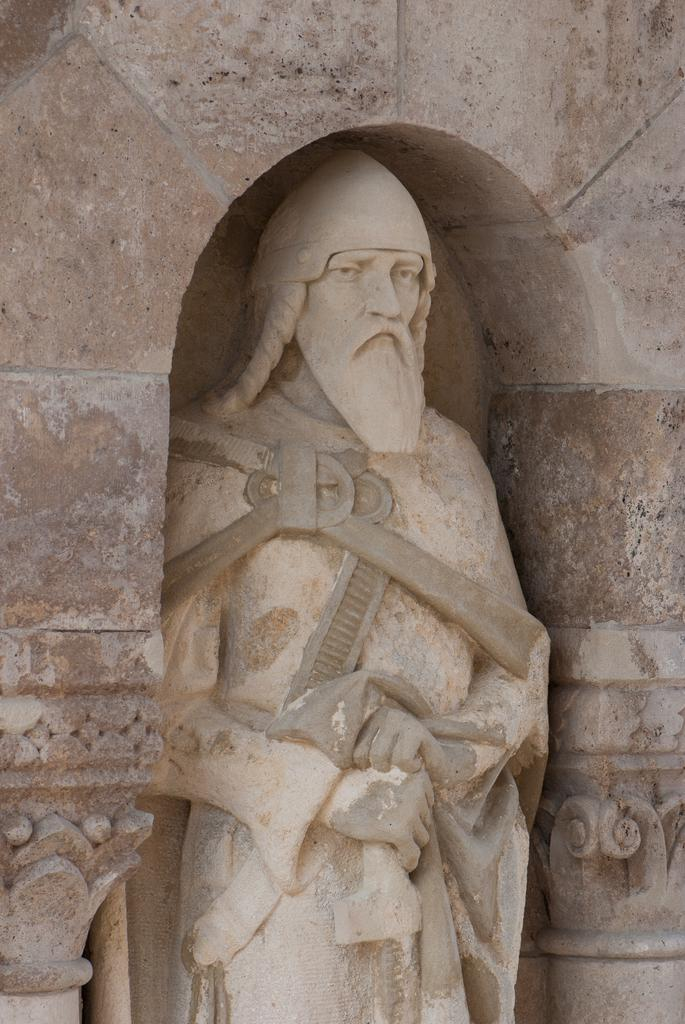What is the main subject of the image? There is a statue in the image. Can you describe the statue? The statue is of a man. What type of voice does the statue have in the image? The statue does not have a voice, as it is an inanimate object. Is there a committee meeting taking place around the statue in the image? There is no indication of a committee meeting or any people in the image; it only features the statue of a man. 